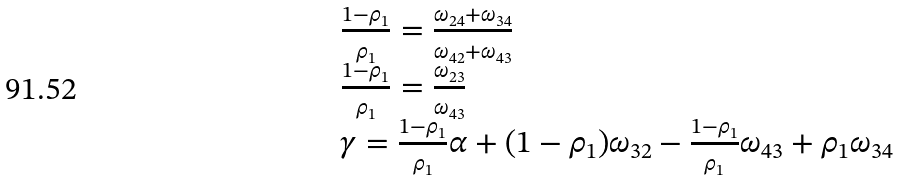<formula> <loc_0><loc_0><loc_500><loc_500>\begin{array} { l } \frac { 1 - \rho _ { 1 } } { \rho _ { 1 } } = \frac { \omega _ { 2 4 } + \omega _ { 3 4 } } { \omega _ { 4 2 } + \omega _ { 4 3 } } \\ \frac { 1 - \rho _ { 1 } } { \rho _ { 1 } } = \frac { \omega _ { 2 3 } } { \omega _ { 4 3 } } \\ \gamma = \frac { 1 - \rho _ { 1 } } { \rho _ { 1 } } \alpha + ( 1 - \rho _ { 1 } ) \omega _ { 3 2 } - \frac { 1 - \rho _ { 1 } } { \rho _ { 1 } } \omega _ { 4 3 } + \rho _ { 1 } \omega _ { 3 4 } \end{array}</formula> 